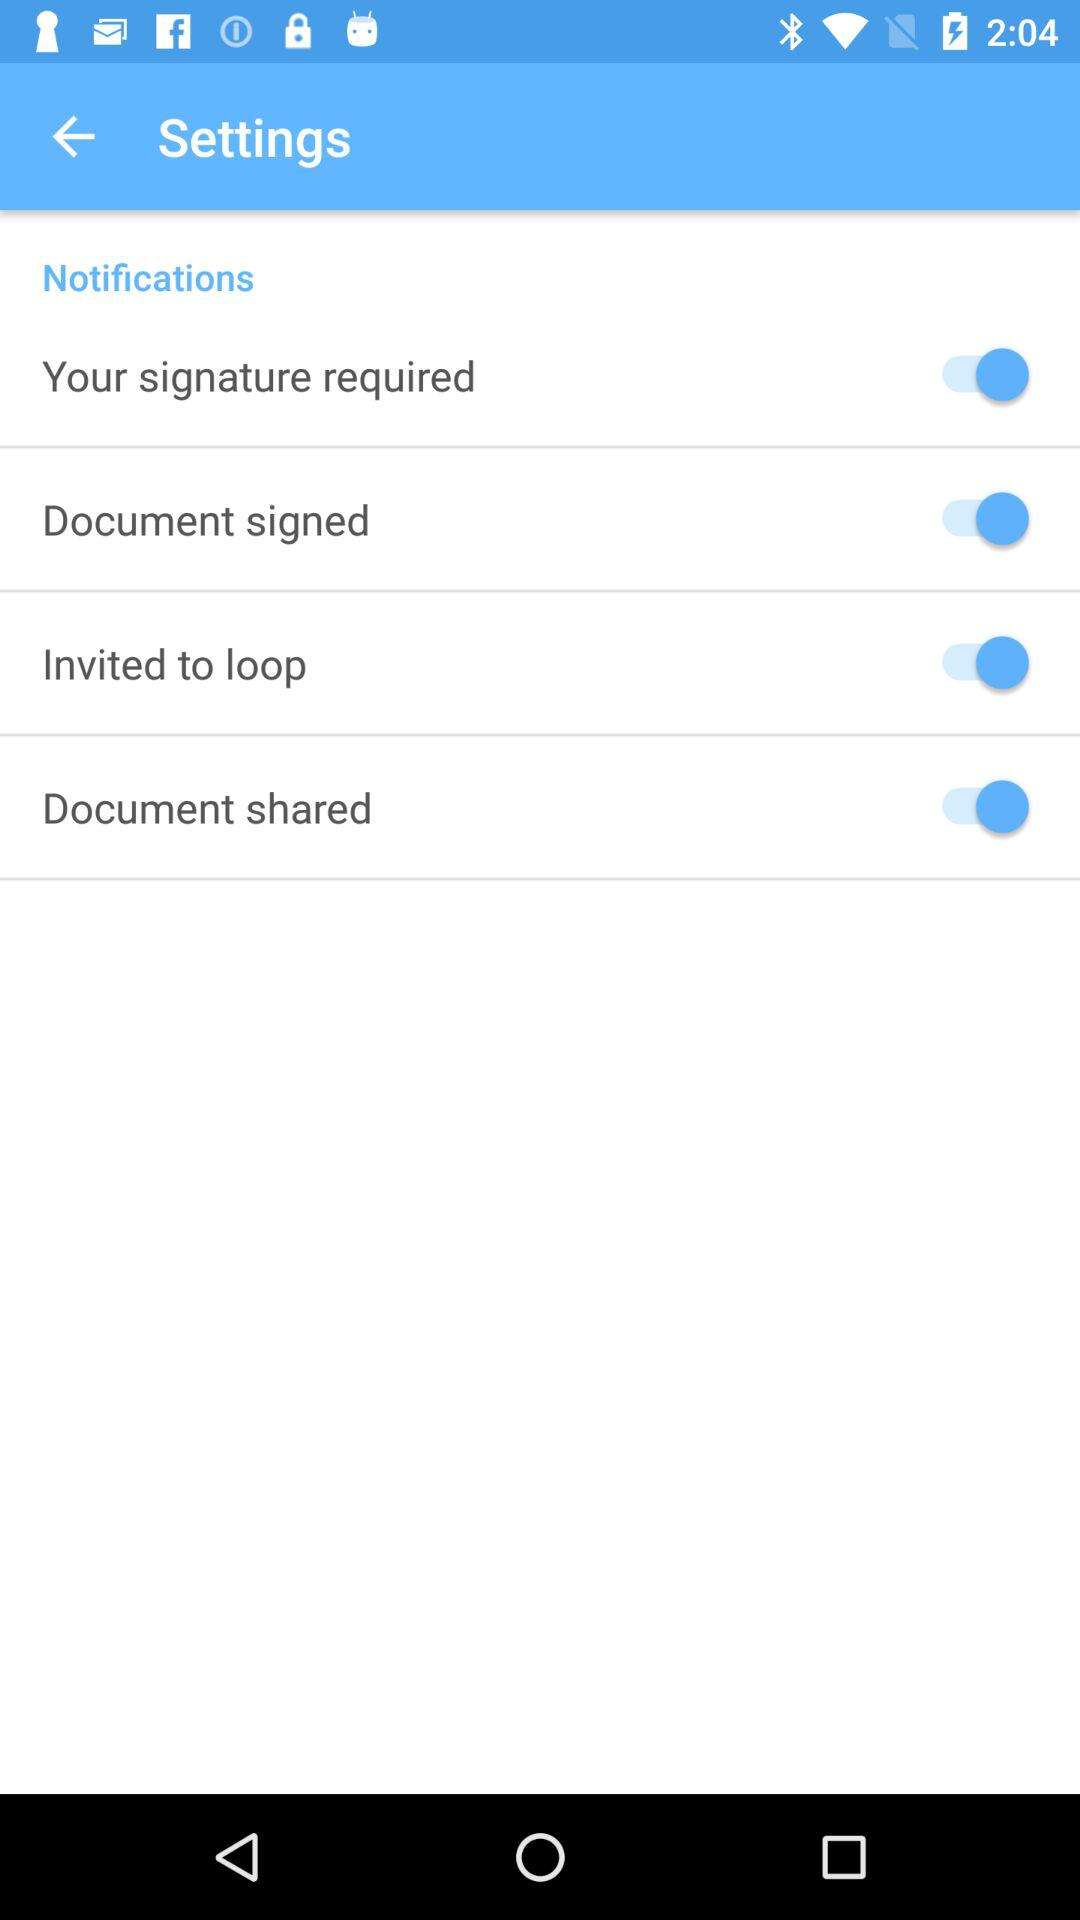How many notifications are there?
Answer the question using a single word or phrase. 4 